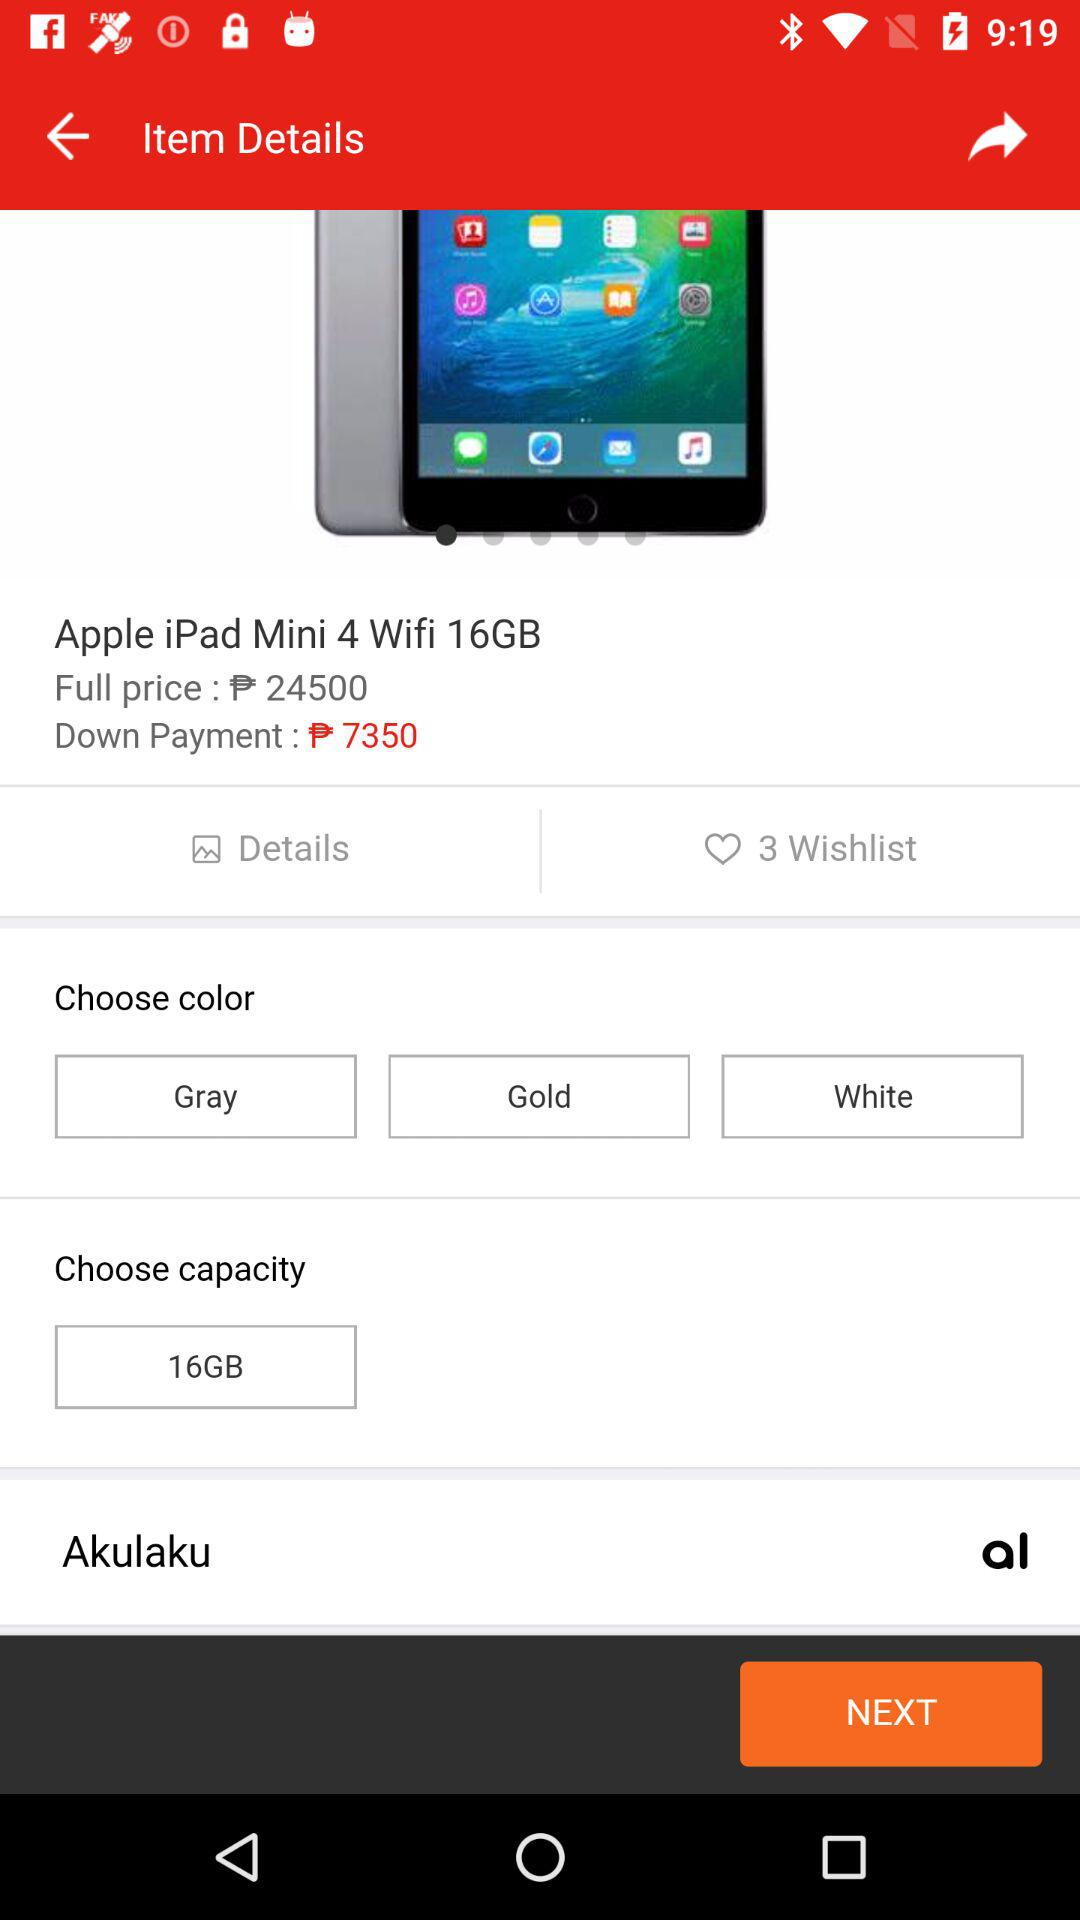How many colors are there to choose from?
Answer the question using a single word or phrase. 3 